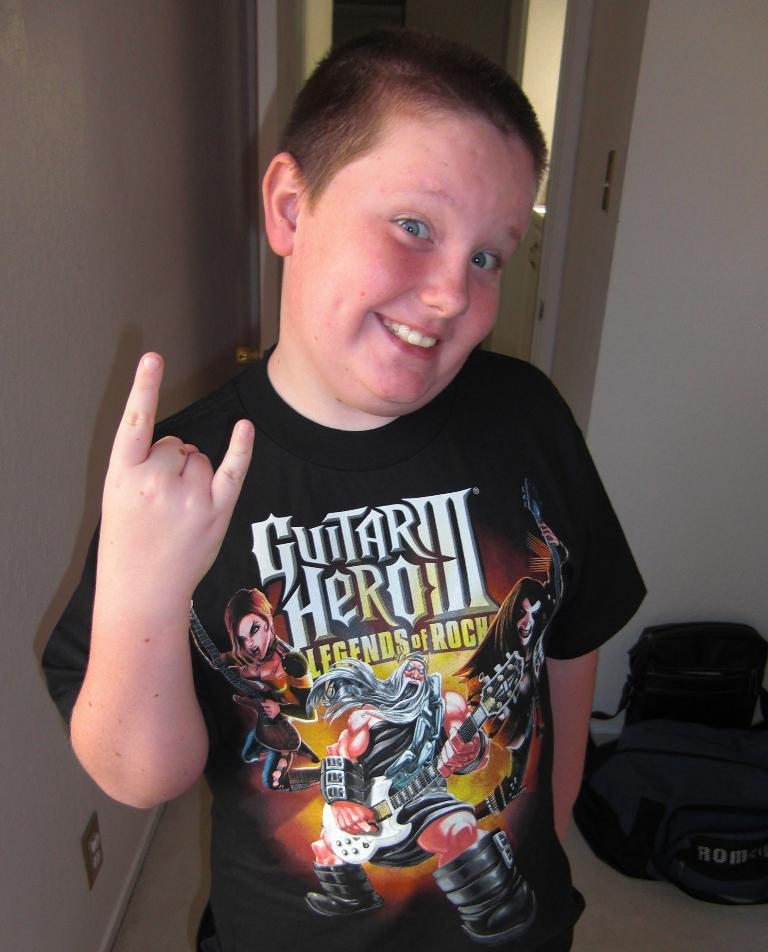What is the main subject of the image? The main subject of the image is a kid. What is the kid wearing in the image? The kid is wearing a black T-shirt. What is the kid doing in the image? The kid is standing and posing for a photograph. What can be seen in the background of the image? There are two bags and a door in the background of the image. What type of wool is being used to make the flag in the image? There is no flag present in the image, so it is not possible to determine the type of wool being used. 